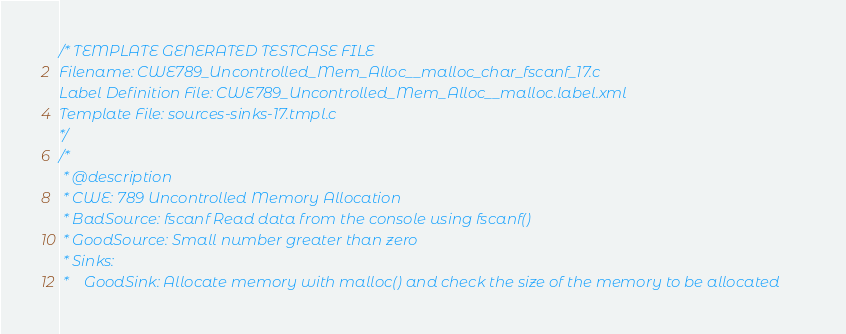Convert code to text. <code><loc_0><loc_0><loc_500><loc_500><_C_>/* TEMPLATE GENERATED TESTCASE FILE
Filename: CWE789_Uncontrolled_Mem_Alloc__malloc_char_fscanf_17.c
Label Definition File: CWE789_Uncontrolled_Mem_Alloc__malloc.label.xml
Template File: sources-sinks-17.tmpl.c
*/
/*
 * @description
 * CWE: 789 Uncontrolled Memory Allocation
 * BadSource: fscanf Read data from the console using fscanf()
 * GoodSource: Small number greater than zero
 * Sinks:
 *    GoodSink: Allocate memory with malloc() and check the size of the memory to be allocated</code> 